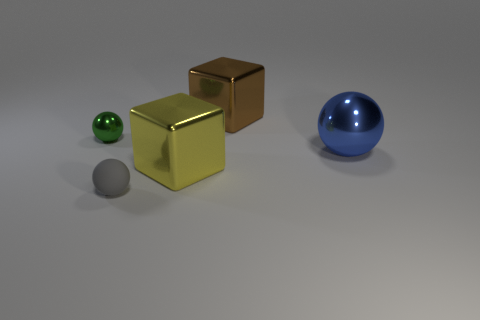Subtract all yellow balls. Subtract all blue blocks. How many balls are left? 3 Add 2 gray rubber things. How many objects exist? 7 Subtract all spheres. How many objects are left? 2 Add 1 gray spheres. How many gray spheres are left? 2 Add 4 shiny balls. How many shiny balls exist? 6 Subtract 0 gray cubes. How many objects are left? 5 Subtract all small gray objects. Subtract all small green metallic objects. How many objects are left? 3 